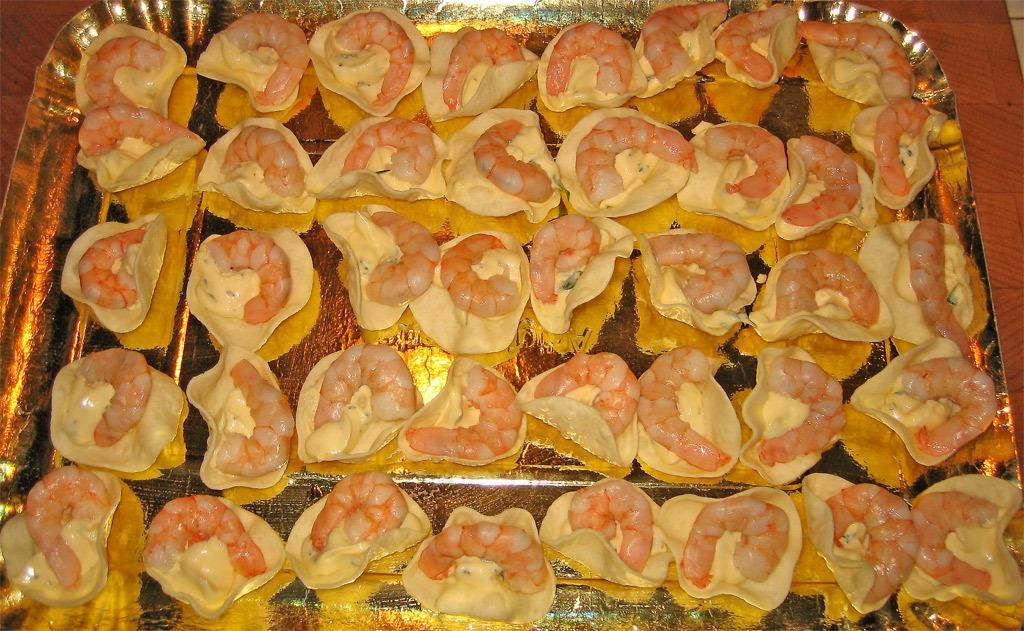What type of food is visible in the image? There are prawns in the image. How are the prawns arranged in the image? The prawns are placed on a plate. What is the color of the plate? The plate is in gold color. What is the color of the table on which the plate is placed? The table is in brown color. How many friends or sisters are sitting at the table with the gold plate in the image? There is no information about friends or sisters in the image; it only shows prawns on a gold plate placed on a brown table. 